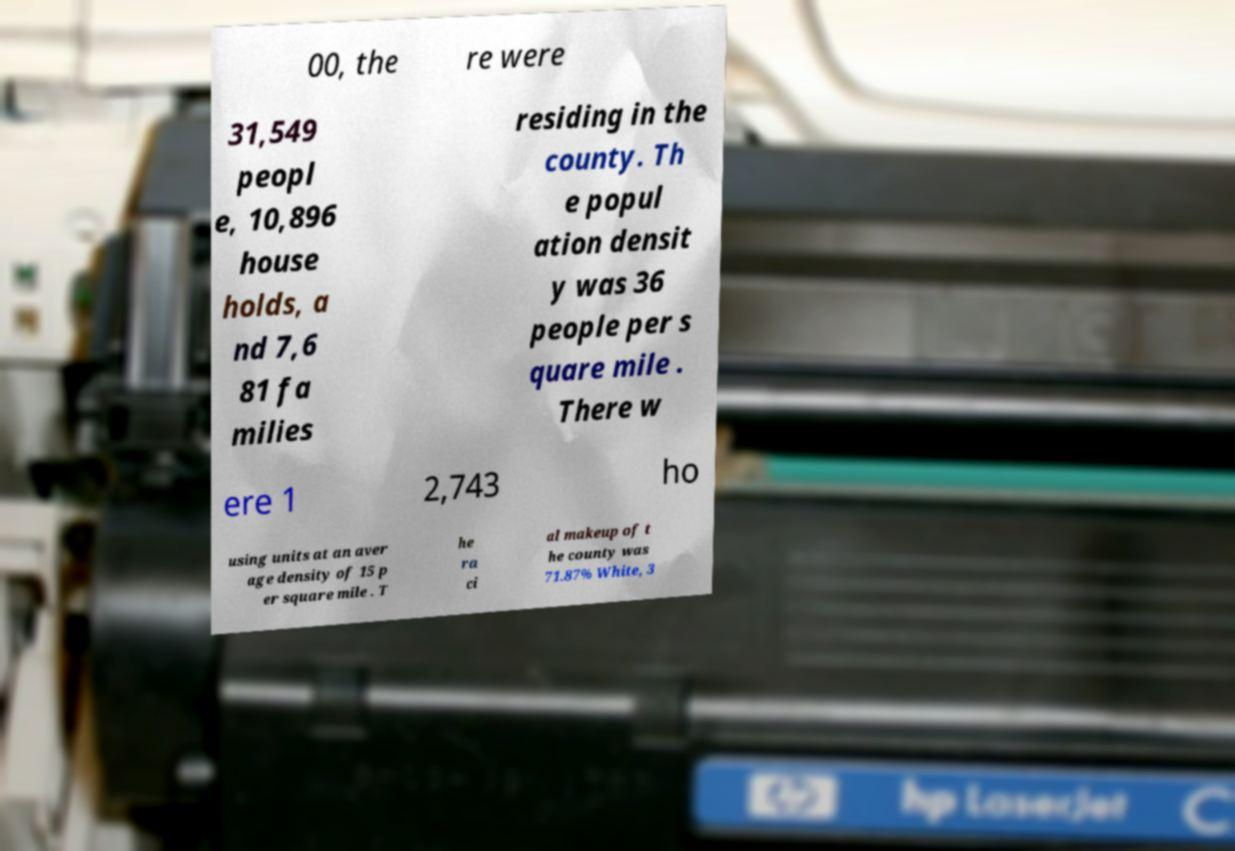I need the written content from this picture converted into text. Can you do that? 00, the re were 31,549 peopl e, 10,896 house holds, a nd 7,6 81 fa milies residing in the county. Th e popul ation densit y was 36 people per s quare mile . There w ere 1 2,743 ho using units at an aver age density of 15 p er square mile . T he ra ci al makeup of t he county was 71.87% White, 3 